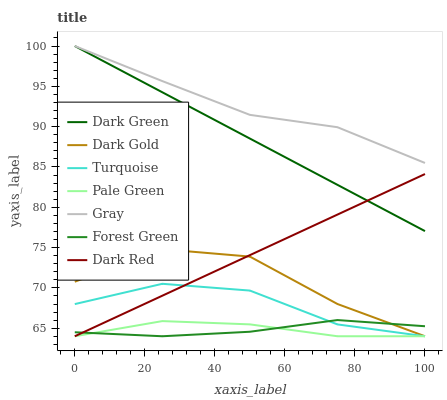Does Turquoise have the minimum area under the curve?
Answer yes or no. No. Does Turquoise have the maximum area under the curve?
Answer yes or no. No. Is Turquoise the smoothest?
Answer yes or no. No. Is Turquoise the roughest?
Answer yes or no. No. Does Dark Green have the lowest value?
Answer yes or no. No. Does Turquoise have the highest value?
Answer yes or no. No. Is Turquoise less than Gray?
Answer yes or no. Yes. Is Gray greater than Dark Red?
Answer yes or no. Yes. Does Turquoise intersect Gray?
Answer yes or no. No. 